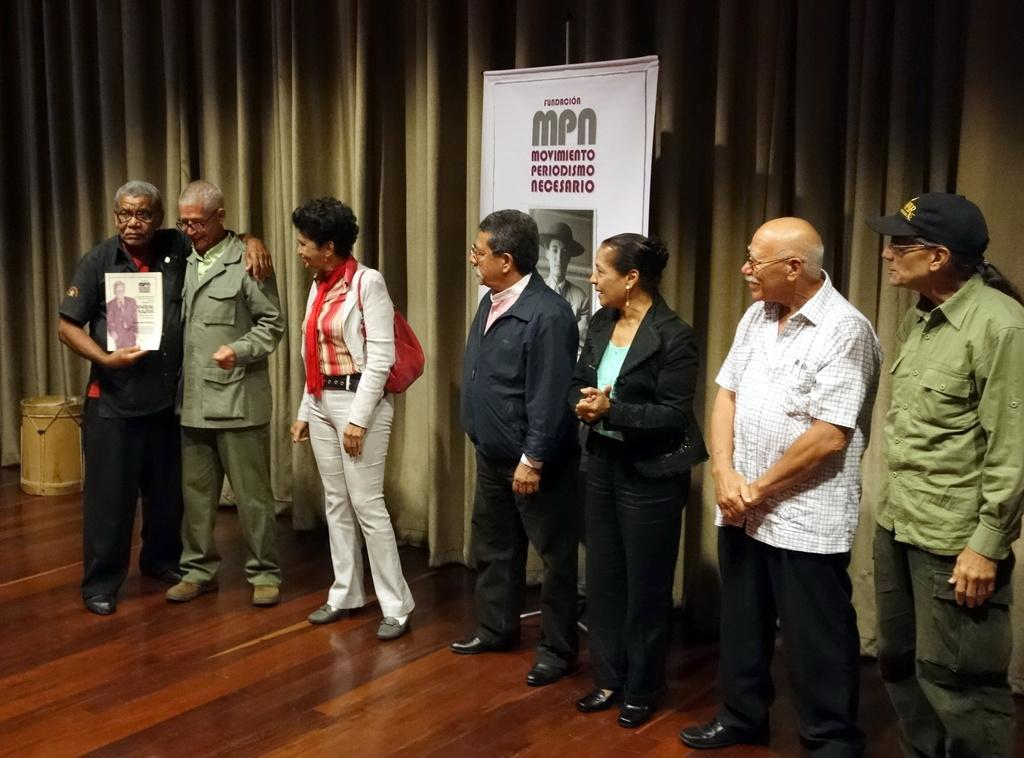What is happening in the center of the image? There are people standing in the center of the image. Can you describe the man on the left side of the image? The man is standing on the left side of the image, and he is holding a paper in his hand. What can be seen in the background of the image? There is a board and a curtain in the background of the image. What type of fork is being used by the people in the image? There is no fork present in the image. What kind of apparatus is the man using to hold the paper? The man is simply holding the paper with his hand; there is no apparatus involved. 